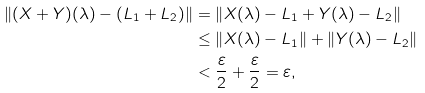Convert formula to latex. <formula><loc_0><loc_0><loc_500><loc_500>\left \| ( X + Y ) ( \lambda ) - ( L _ { 1 } + L _ { 2 } ) \right \| & = \left \| X ( \lambda ) - L _ { 1 } + Y ( \lambda ) - L _ { 2 } \right \| \\ & \leq \left \| X ( \lambda ) - L _ { 1 } \right \| + \left \| Y ( \lambda ) - L _ { 2 } \right \| \\ & < \frac { \varepsilon } { 2 } + \frac { \varepsilon } { 2 } = \varepsilon ,</formula> 